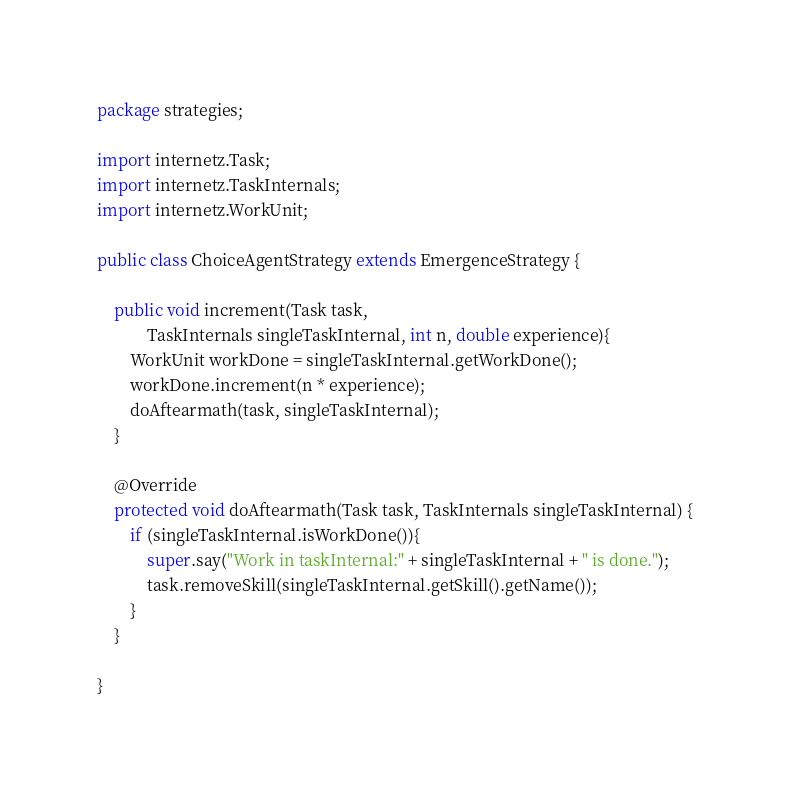<code> <loc_0><loc_0><loc_500><loc_500><_Java_>package strategies;

import internetz.Task;
import internetz.TaskInternals;
import internetz.WorkUnit;

public class ChoiceAgentStrategy extends EmergenceStrategy {
	
	public void increment(Task task,
			TaskInternals singleTaskInternal, int n, double experience){
		WorkUnit workDone = singleTaskInternal.getWorkDone();
		workDone.increment(n * experience);
		doAftearmath(task, singleTaskInternal);
	}

	@Override
	protected void doAftearmath(Task task, TaskInternals singleTaskInternal) {
		if (singleTaskInternal.isWorkDone()){
			super.say("Work in taskInternal:" + singleTaskInternal + " is done.");
			task.removeSkill(singleTaskInternal.getSkill().getName());
		}
	}

}
</code> 